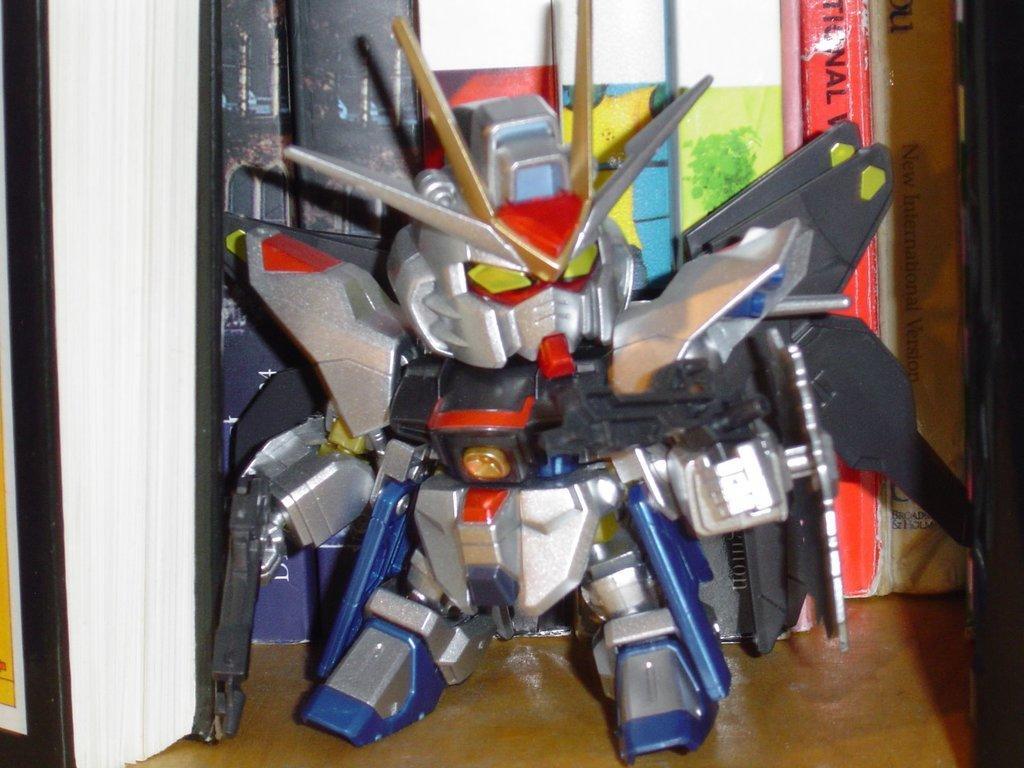How would you summarize this image in a sentence or two? In this image there are tools in the center. 